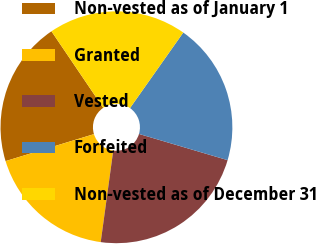Convert chart. <chart><loc_0><loc_0><loc_500><loc_500><pie_chart><fcel>Non-vested as of January 1<fcel>Granted<fcel>Vested<fcel>Forfeited<fcel>Non-vested as of December 31<nl><fcel>20.24%<fcel>18.12%<fcel>22.59%<fcel>19.8%<fcel>19.25%<nl></chart> 